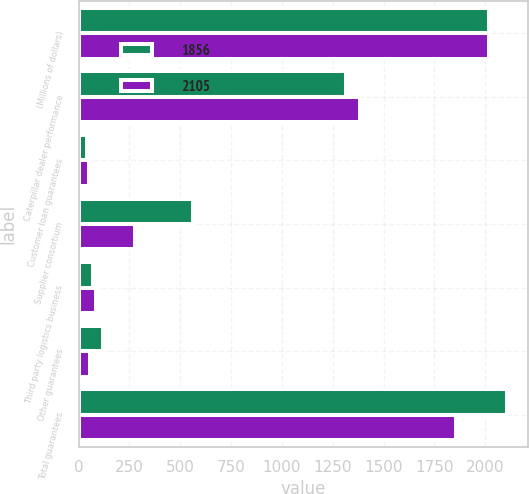Convert chart. <chart><loc_0><loc_0><loc_500><loc_500><stacked_bar_chart><ecel><fcel>(Millions of dollars)<fcel>Caterpillar dealer performance<fcel>Customer loan guarantees<fcel>Supplier consortium<fcel>Third party logistics business<fcel>Other guarantees<fcel>Total guarantees<nl><fcel>1856<fcel>2017<fcel>1313<fcel>40<fcel>565<fcel>69<fcel>118<fcel>2105<nl><fcel>2105<fcel>2016<fcel>1384<fcel>51<fcel>278<fcel>87<fcel>56<fcel>1856<nl></chart> 